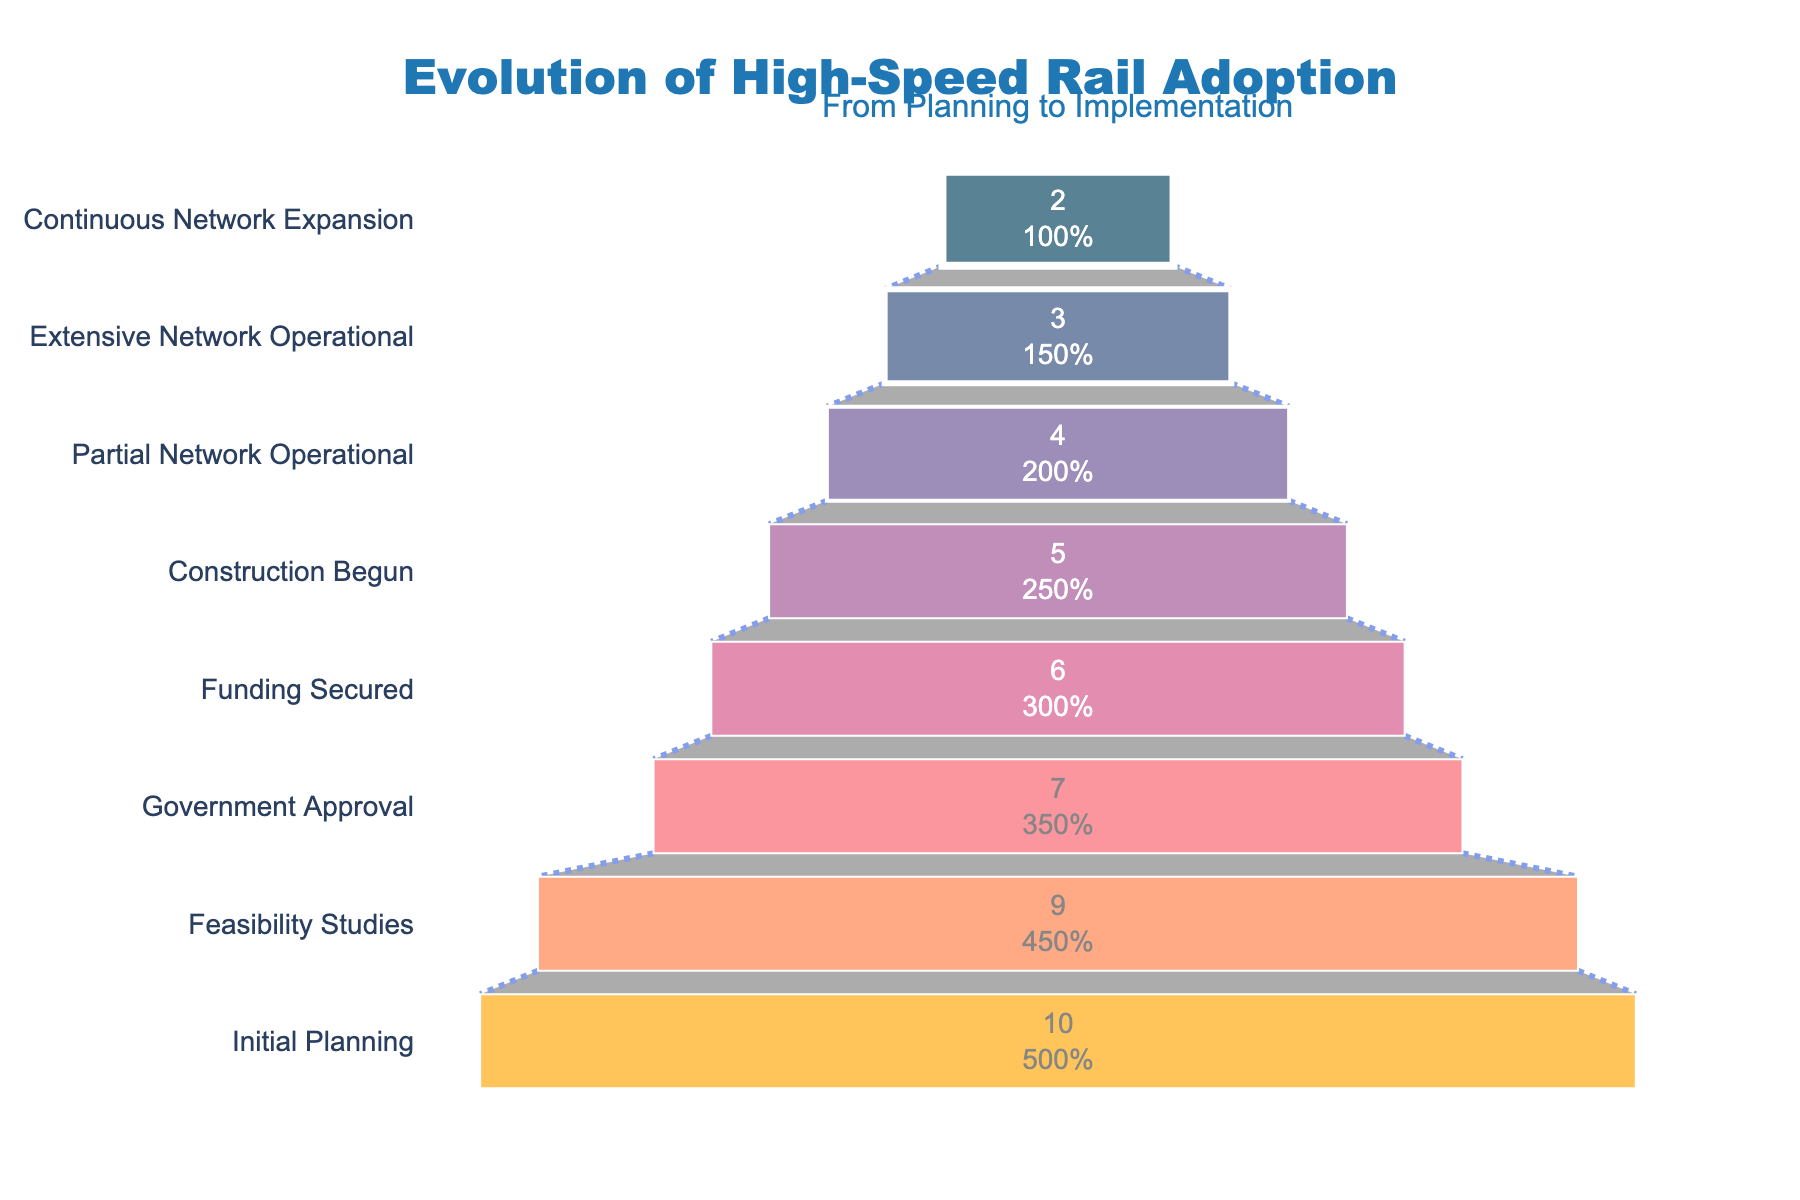How many countries are in the Initial Planning stage? The Funnel Chart shows the number of countries in each stage of high-speed rail adoption. For the Initial Planning stage, it indicates 10 countries.
Answer: 10 Which stage has the fewest number of countries? By looking at the Funnel Chart, we see that the smallest segment is at the bottom, labeled Continuous Network Expansion, which shows 2 countries.
Answer: Continuous Network Expansion How many countries drop out between the Funding Secured stage and the Government Approval stage? From the Government Approval stage, there are 7 countries, and from the Funding Secured stage, there are 6 countries. To find the number of countries that drop out, subtract the lower stage's count from the higher stage's count: 7 - 6.
Answer: 1 What percentage of initial countries reach the Extensive Network Operational stage? The percentage is shown inside the funnel chart segment for the Extensive Network Operational stage. Starting with 10 countries initially, the percentage for 3 countries that reach the Extensive Network Operational stage is 30%.
Answer: 30% Which stages have more than half of the initial countries dropping out? Considering the initial number to be 10, more than half dropping out means fewer than 5 countries (10 / 2 = 5). The stages with fewer than 5 countries are Construction Begun, Partial Network Operational, Extensive Network Operational, and Continuous Network Expansion.
Answer: Construction Begun, Partial Network Operational, Extensive Network Operational, Continuous Network Expansion How many countries move from Partial Network Operational to Extensive Network Operational? The Partial Network Operational stage has 4 countries, and the Extensive Network Operational stage has 3 countries. The difference, 4 - 3, gives us the number of countries that move on to the next stage.
Answer: 1 Which stages contain the same number of countries? Observing the Funnel Chart, the stages Feasibility Studies and Government Approval show continuity in the number of countries moving from one stage to another without dropouts. Also, stages Partial Network Operational and Extensive Network Operational have only a 1 country difference, but not the same number.
Answer: No stages contain the exact same number of countries At what stage do half of the countries have already dropped out? Starting with 10 countries, half would be 5. We see that the stage Construction Begun has exactly 5 countries.
Answer: Construction Begun What is the ratio of countries in Construction Begun to countries in Government Approval? The Funnel Chart shows 5 countries in the Construction Begun stage and 7 countries in the Government Approval stage. The ratio is 5:7.
Answer: 5:7 